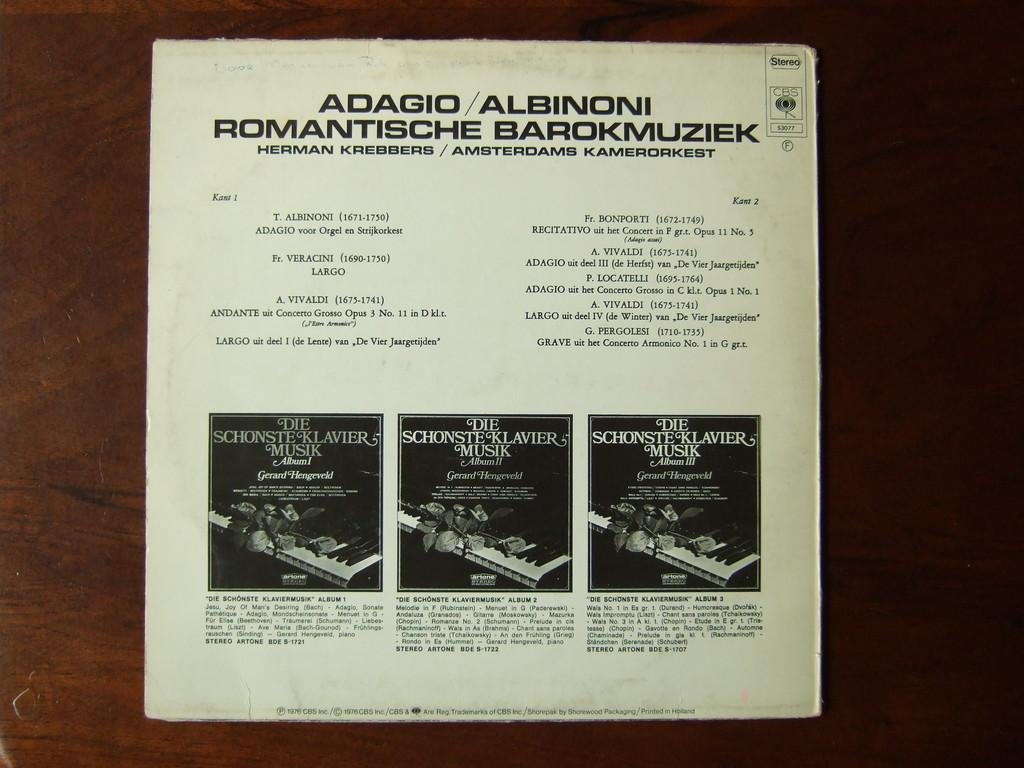What is present on the wooden surface in the image? There is a paper on the wooden surface in the image. What is written or depicted on the paper? The paper has text and three images of a piano on it. What type of seed is being planted by the mother in the image? There is no mother or seed present in the image; it only features a paper with text and images of a piano on a wooden surface. 